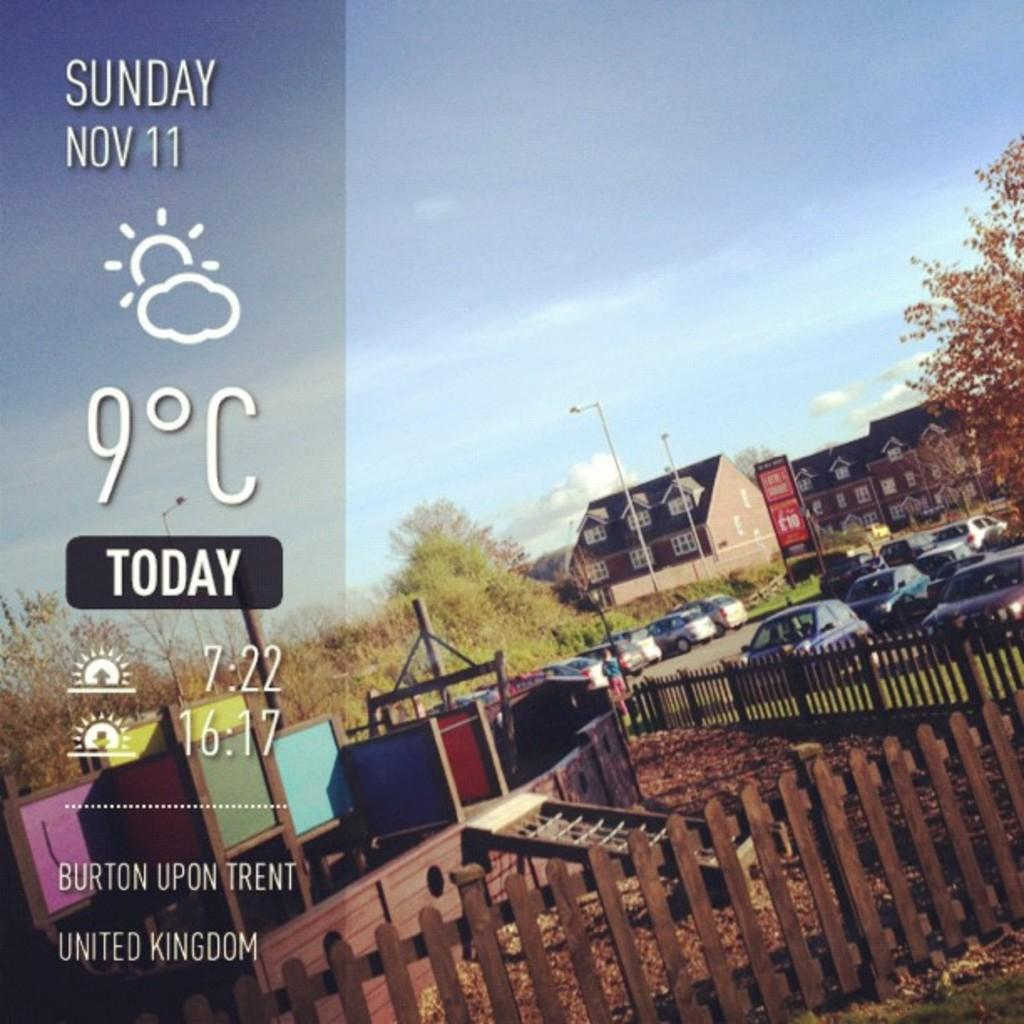<image>
Write a terse but informative summary of the picture. Screen which shows a picture of a town as well as the time at 7:22. 